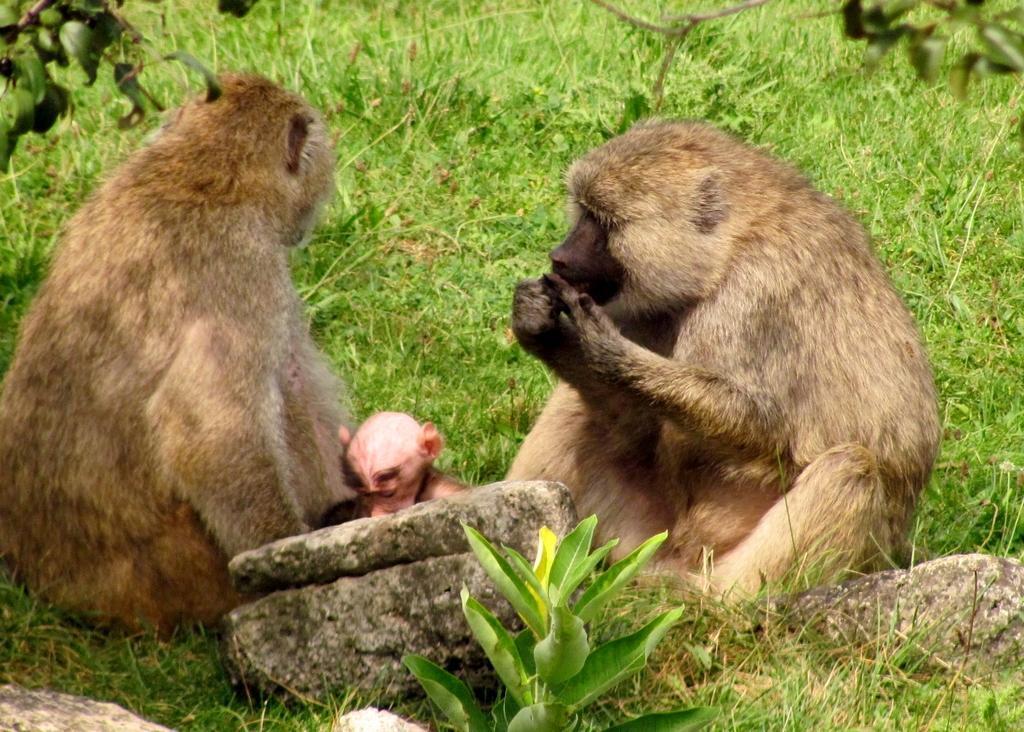How would you summarize this image in a sentence or two? This picture is clicked outside. In the center we can see the two monkeys sitting on the ground and we can see the green grass, plants, rocks and some other objects. 